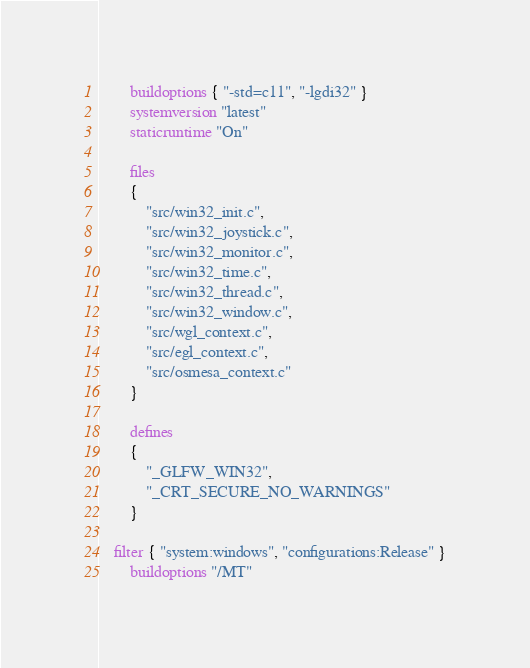<code> <loc_0><loc_0><loc_500><loc_500><_Lua_>		buildoptions { "-std=c11", "-lgdi32" }
		systemversion "latest"
		staticruntime "On"

		files
		{
			"src/win32_init.c",
			"src/win32_joystick.c",
			"src/win32_monitor.c",
			"src/win32_time.c",
			"src/win32_thread.c",
			"src/win32_window.c",
			"src/wgl_context.c",
			"src/egl_context.c",
			"src/osmesa_context.c"
		}

		defines
		{
			"_GLFW_WIN32",
			"_CRT_SECURE_NO_WARNINGS"
		}

	filter { "system:windows", "configurations:Release" }
		buildoptions "/MT"
</code> 